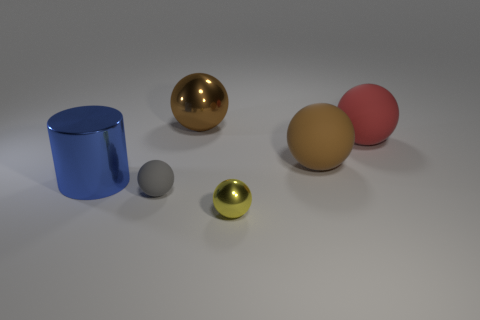Subtract all yellow spheres. How many spheres are left? 4 Subtract all brown balls. How many balls are left? 3 Subtract 2 balls. How many balls are left? 3 Subtract all spheres. How many objects are left? 1 Add 1 blue shiny cylinders. How many objects exist? 7 Add 2 small gray spheres. How many small gray spheres are left? 3 Add 5 brown shiny objects. How many brown shiny objects exist? 6 Subtract 0 red cubes. How many objects are left? 6 Subtract all green balls. Subtract all gray blocks. How many balls are left? 5 Subtract all cyan cubes. How many cyan cylinders are left? 0 